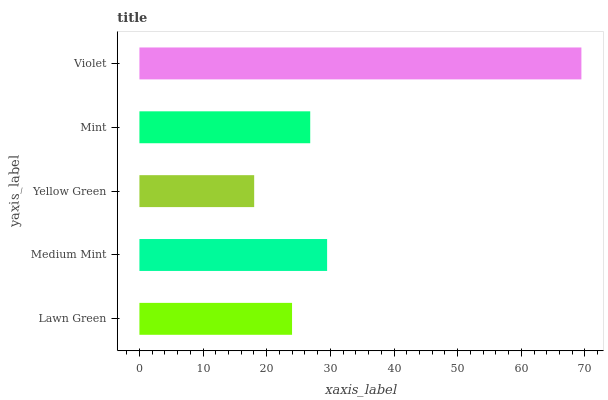Is Yellow Green the minimum?
Answer yes or no. Yes. Is Violet the maximum?
Answer yes or no. Yes. Is Medium Mint the minimum?
Answer yes or no. No. Is Medium Mint the maximum?
Answer yes or no. No. Is Medium Mint greater than Lawn Green?
Answer yes or no. Yes. Is Lawn Green less than Medium Mint?
Answer yes or no. Yes. Is Lawn Green greater than Medium Mint?
Answer yes or no. No. Is Medium Mint less than Lawn Green?
Answer yes or no. No. Is Mint the high median?
Answer yes or no. Yes. Is Mint the low median?
Answer yes or no. Yes. Is Medium Mint the high median?
Answer yes or no. No. Is Lawn Green the low median?
Answer yes or no. No. 